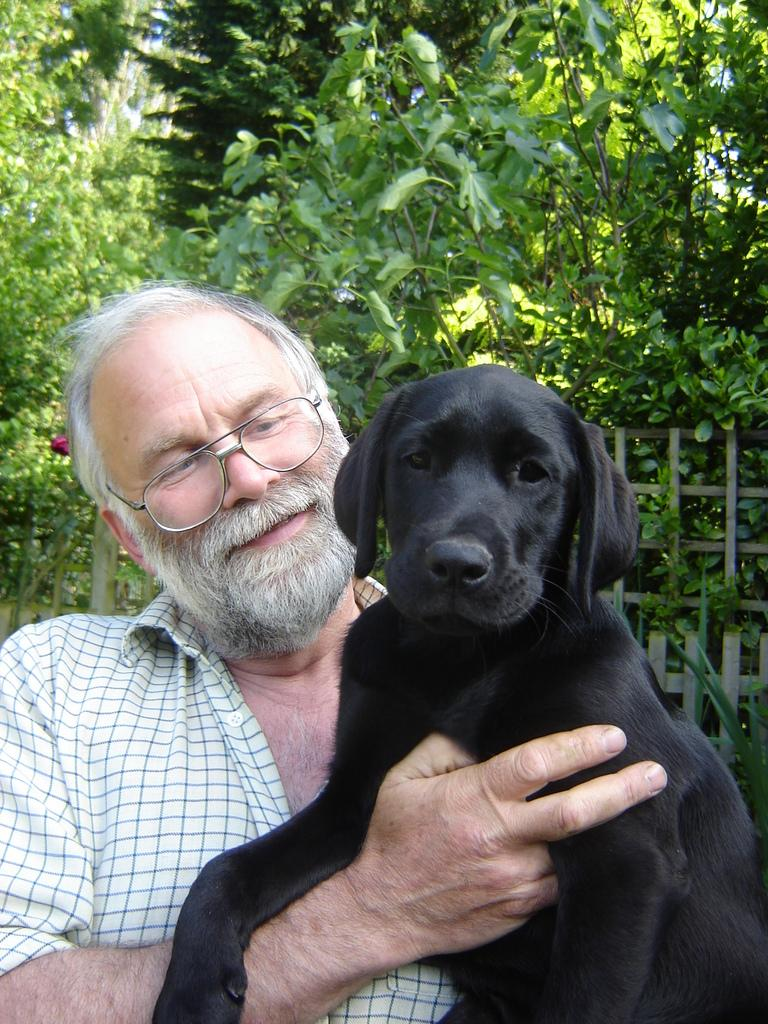Who is the main subject in the image? There is an old man in the image. What is the old man holding in the image? The old man is holding a dog. What can be seen in the background behind the old man? There are trees and plants behind the old man. What type of ink is being used by the old man to write a letter in the image? There is no indication in the image that the old man is writing a letter or using ink. 